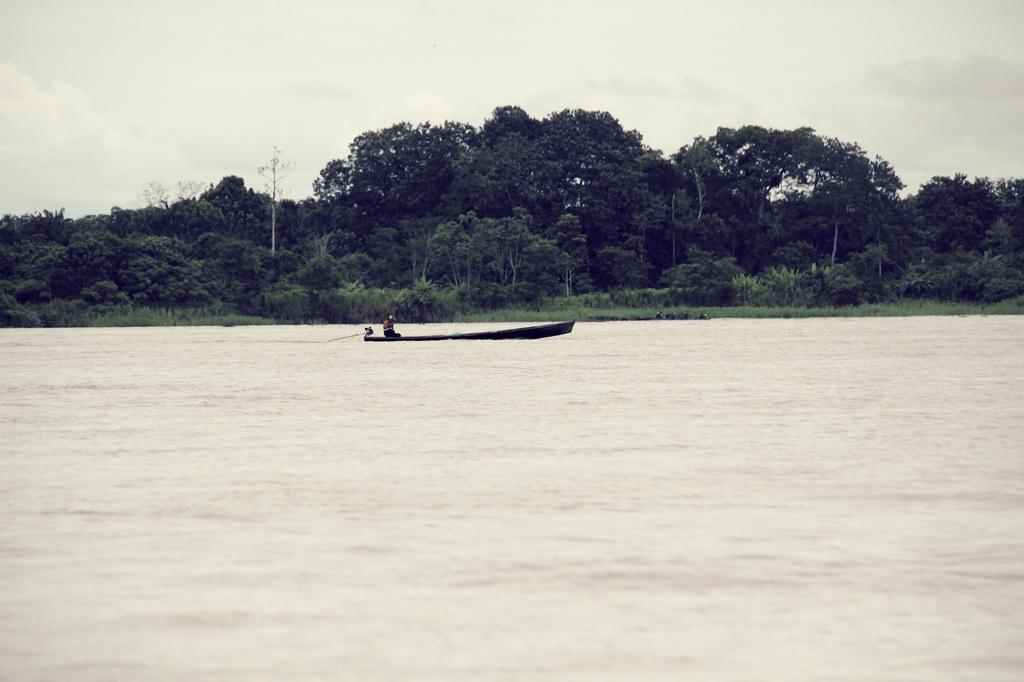What is visible in the foreground of the picture? There is water in the foreground of the picture. What is floating on the water in the picture? There is a boat in the water. What can be seen in the center of the picture? There are trees, plants, and grass in the center of the picture. How would you describe the sky in the picture? The sky is cloudy in the picture. Can you see any rice being cooked on a stove in the picture? There is no stove or rice visible in the picture; it features water, a boat, trees, plants, grass, and a cloudy sky. Is there a doctor wearing a scarf in the center of the picture? There is no doctor or scarf present in the image; it features trees, plants, grass, and a boat in the water. 